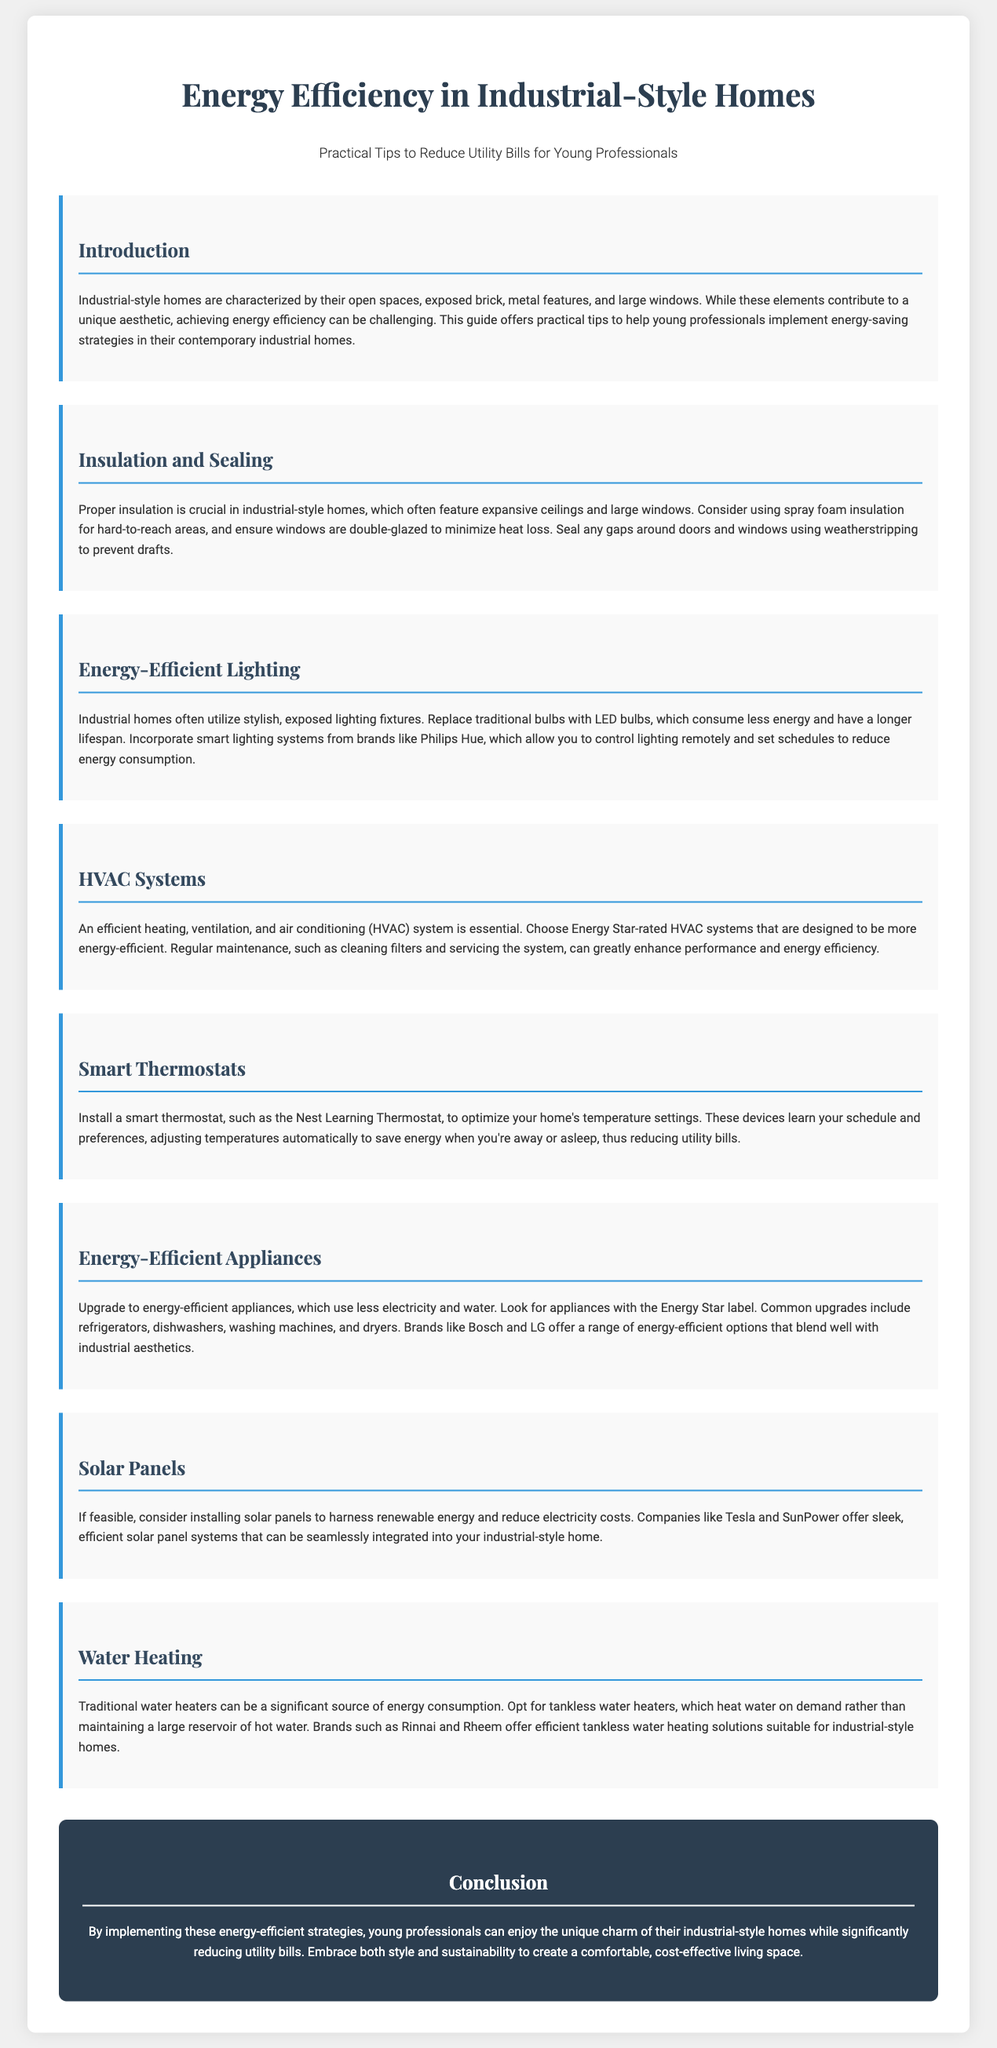What is the primary focus of the guide? The primary focus of the guide is to provide practical tips for young professionals to reduce utility bills in industrial-style homes.
Answer: Reduce utility bills Which insulation method is recommended for hard-to-reach areas? The guide recommends using spray foam insulation for hard-to-reach areas in industrial-style homes.
Answer: Spray foam insulation What type of light bulbs should be used in industrial-style homes? The guide suggests replacing traditional bulbs with LED bulbs for energy-efficient lighting in industrial-style homes.
Answer: LED bulbs What is the benefit of a smart thermostat according to the guide? A smart thermostat optimizes temperature settings, learning schedules and preferences to save energy and reduce utility bills.
Answer: Saves energy What appliance is mentioned as an upgrade to reduce energy consumption? Energy-efficient refrigerators are mentioned as an upgrade to help reduce energy consumption in homes.
Answer: Refrigerators How do solar panels help in energy efficiency? Solar panels help reduce electricity costs by harnessing renewable energy, according to the guide.
Answer: Reduce electricity costs What kind of water heater is recommended for better energy efficiency? The guide recommends tankless water heaters for better energy efficiency in industrial-style homes.
Answer: Tankless water heaters Which brands offer energy-efficient appliances? The brands Bosch and LG are noted for offering a range of energy-efficient appliances that fit with industrial aesthetics.
Answer: Bosch and LG 